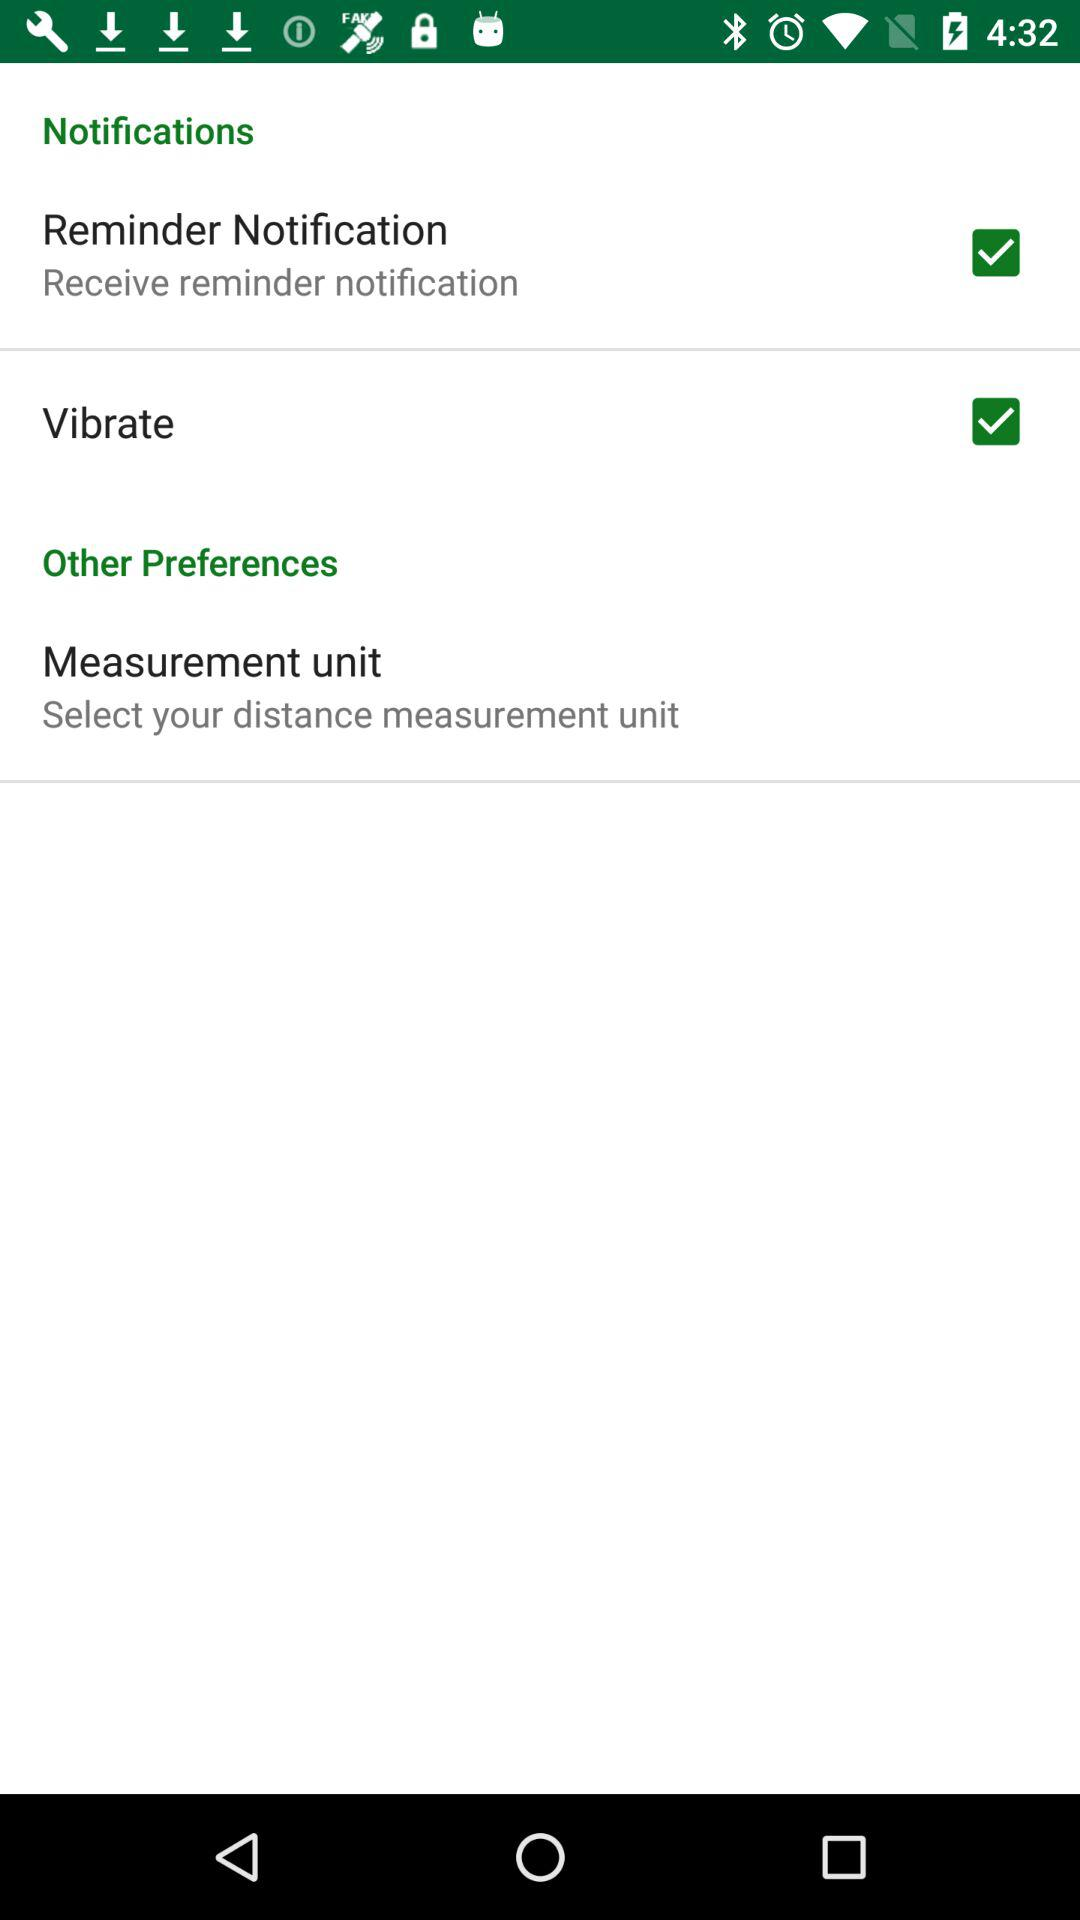What is the checked checkbox? The checked checkboxes are "Reminder Notification" and "Vibrate". 